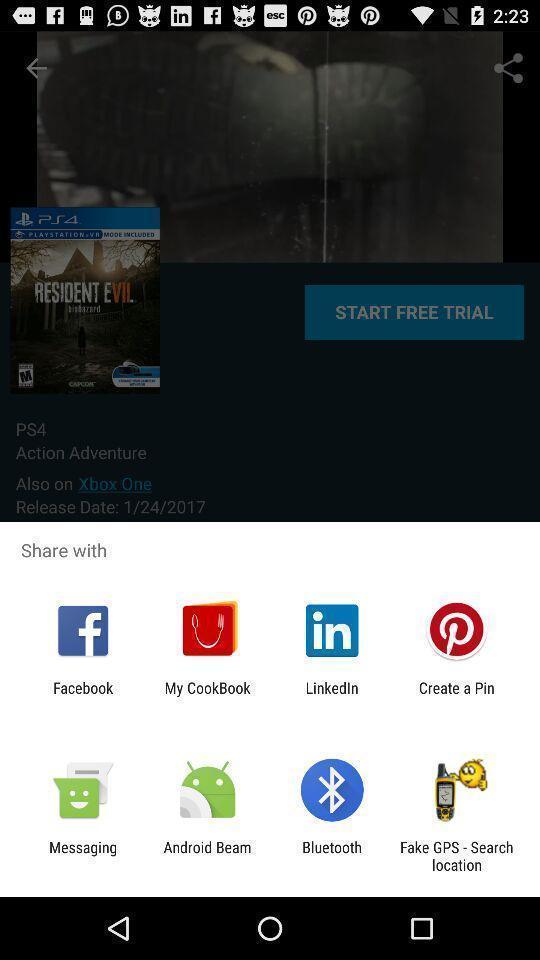Explain what's happening in this screen capture. Pop up displaying different options for sharing the page. 